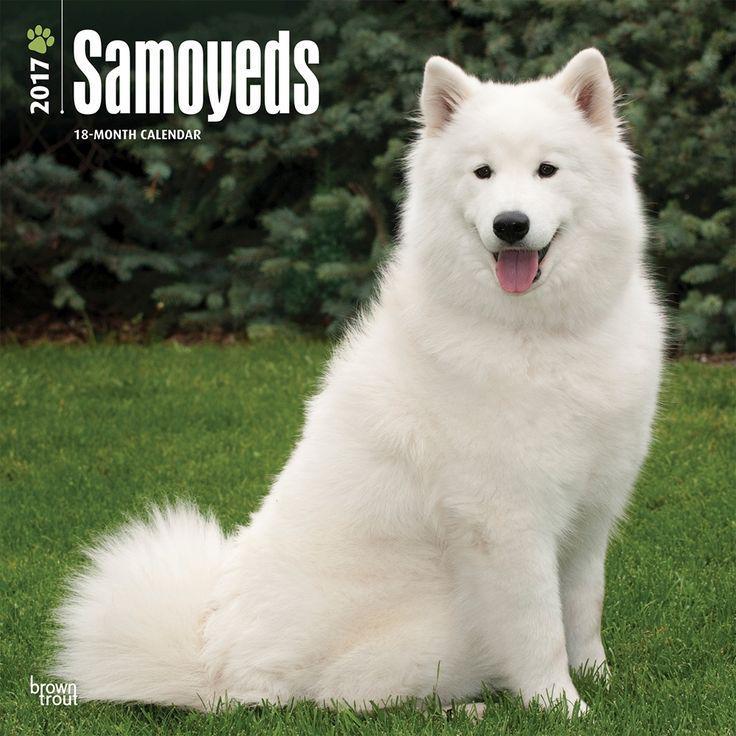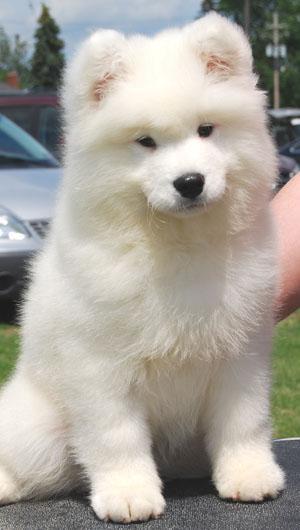The first image is the image on the left, the second image is the image on the right. Given the left and right images, does the statement "There are no more then two white dogs." hold true? Answer yes or no. Yes. 